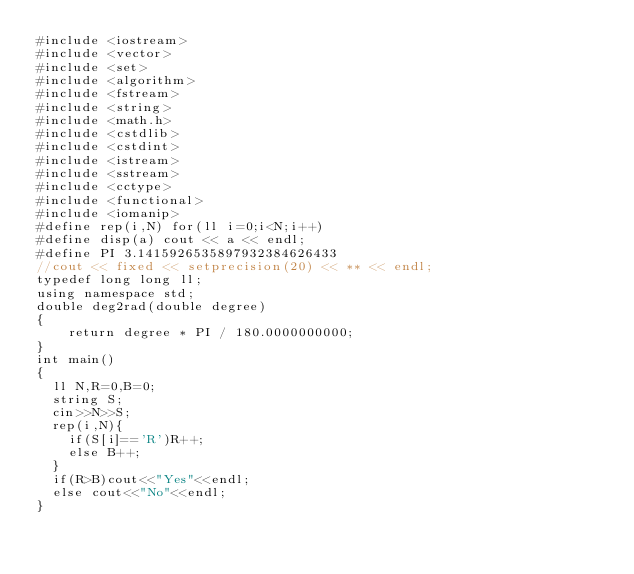<code> <loc_0><loc_0><loc_500><loc_500><_C++_>#include <iostream>
#include <vector>
#include <set>
#include <algorithm>
#include <fstream>
#include <string>
#include <math.h>
#include <cstdlib>
#include <cstdint>
#include <istream>
#include <sstream>
#include <cctype>
#include <functional>
#include <iomanip>
#define rep(i,N) for(ll i=0;i<N;i++)
#define disp(a) cout << a << endl;
#define PI 3.1415926535897932384626433
//cout << fixed << setprecision(20) << ** << endl;
typedef long long ll;
using namespace std;
double deg2rad(double degree)
{
    return degree * PI / 180.0000000000;
}
int main()
{
	ll N,R=0,B=0;
	string S;
	cin>>N>>S;
	rep(i,N){
		if(S[i]=='R')R++;
		else B++;
	}
	if(R>B)cout<<"Yes"<<endl;
	else cout<<"No"<<endl;
}</code> 